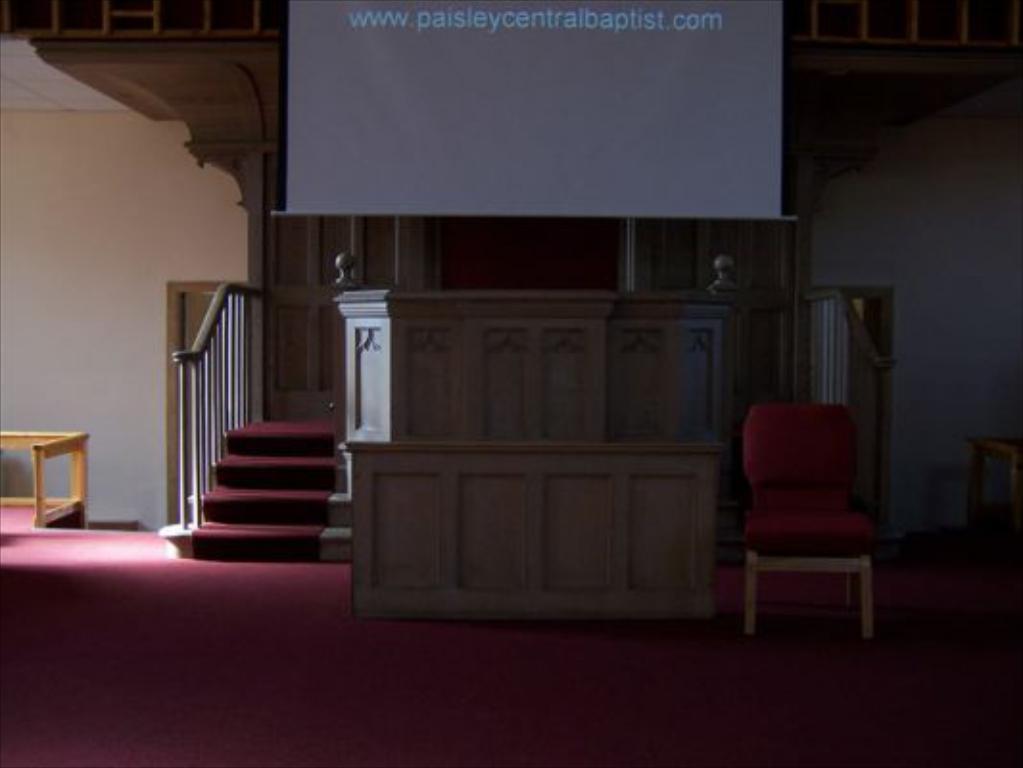Please provide a concise description of this image. In this picture there is a showcase in the center of the image and there are stairs on the right and left side of the showcase, there is a projector screen at the top side of the image, there is a door on the left side of the image, there is a chair on the right side of the image. 